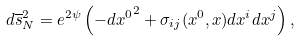<formula> <loc_0><loc_0><loc_500><loc_500>d \overline { s } _ { N } ^ { 2 } = e ^ { 2 \psi } \left ( { - d x ^ { 0 } } ^ { 2 } + \sigma _ { i j } ( x ^ { 0 } , x ) d x ^ { i } d x ^ { j } \right ) ,</formula> 